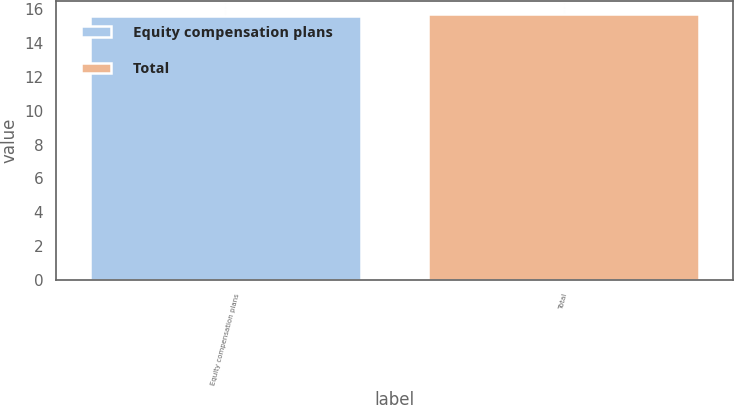<chart> <loc_0><loc_0><loc_500><loc_500><bar_chart><fcel>Equity compensation plans<fcel>Total<nl><fcel>15.61<fcel>15.71<nl></chart> 